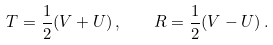Convert formula to latex. <formula><loc_0><loc_0><loc_500><loc_500>T = { \frac { 1 } { 2 } } ( V + U ) \, , \quad R = { \frac { 1 } { 2 } } ( V - U ) \, .</formula> 